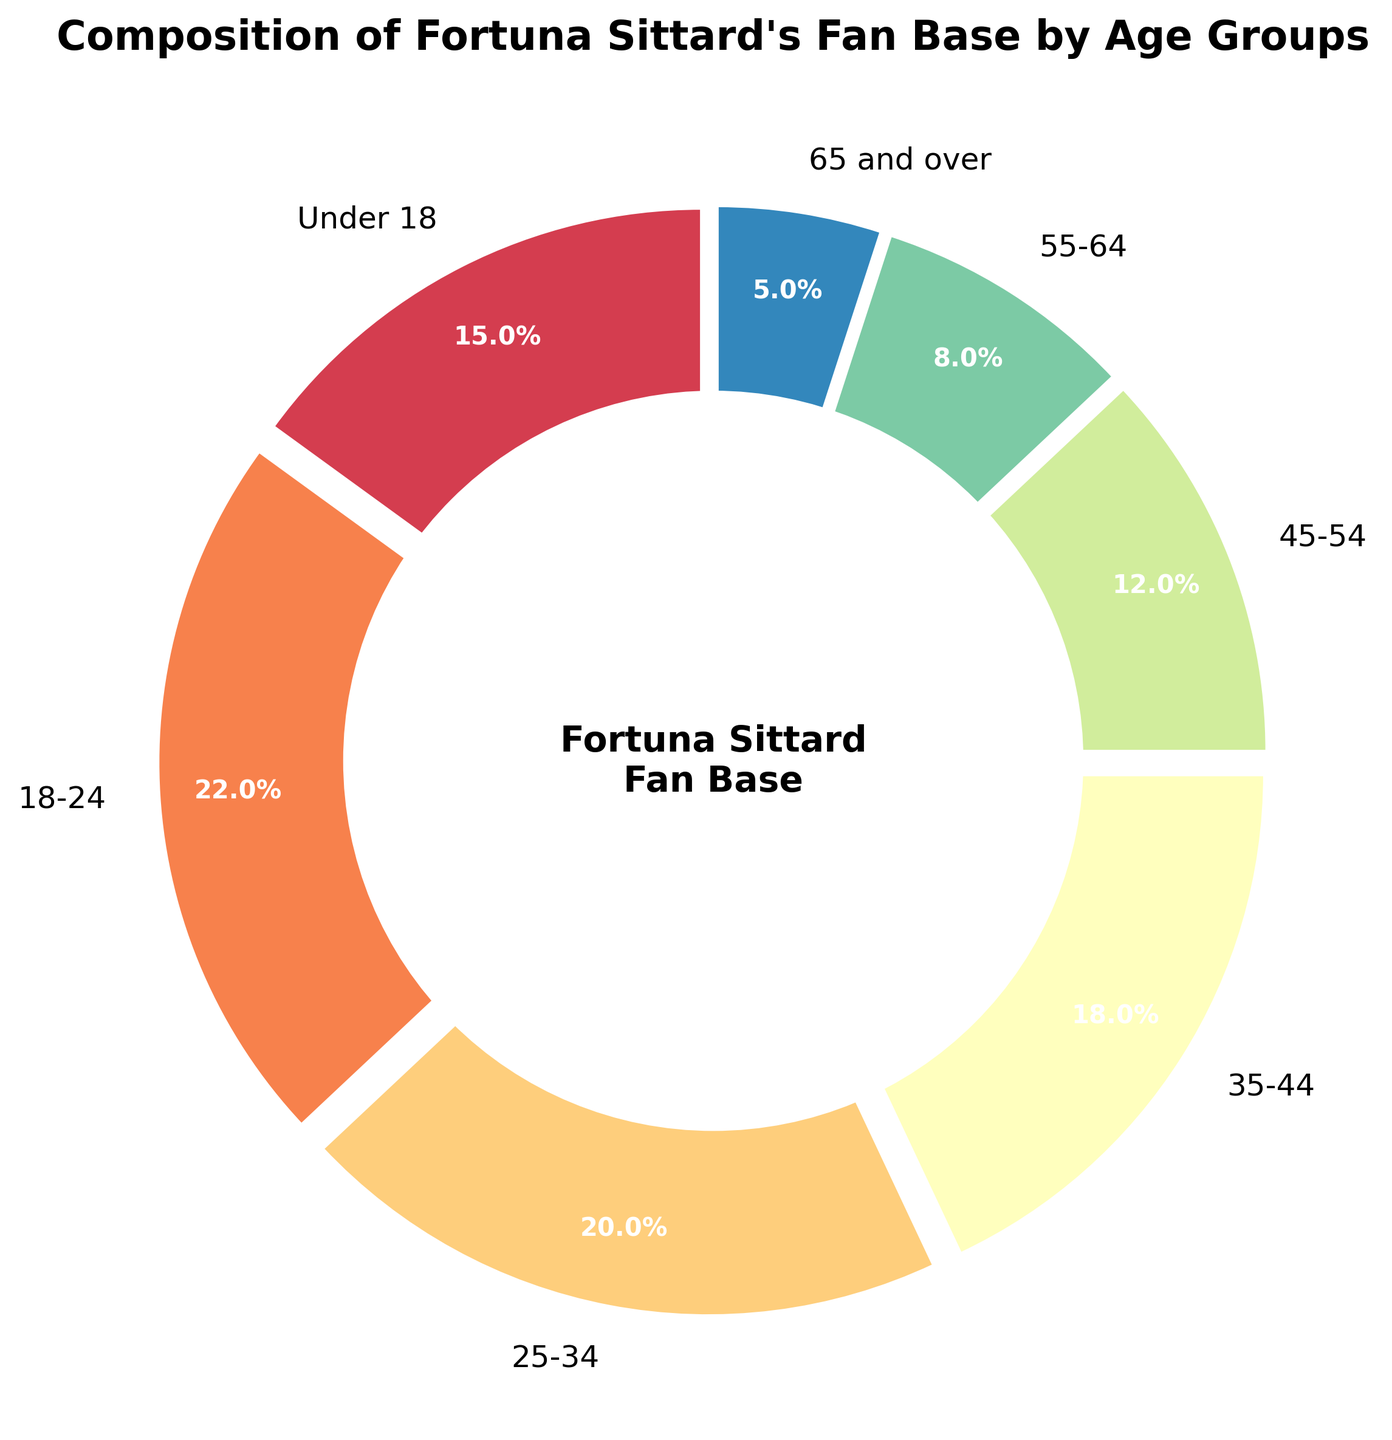What's the largest age group in the fan base? The largest age group in the fan base is identified by the segment of the pie chart with the largest percentage. The 18-24 age group makes up 22% of the fan base.
Answer: 18-24 Which age group contributes the least to the fan base? The age group with the smallest segment of the pie chart represents the smallest contribution. The 65 and over group makes up 5% of the fan base.
Answer: 65 and over What two age groups together make up more than one-third of the fan base? Two age groups need to collectively comprise more than 33.3%. The 18-24 group (22%) and the Under 18 group (15%) together make up 37%.
Answer: 18-24 and Under 18 Which two consecutive age groups together have the closest percentage to 30% of the fan base? Add the percentages of consecutive age groups and compare to 30%. The 25-34 group (20%) combined with the 35-44 group (18%) results in 38%, while the 35-44 and 45-54 groups combined make 30%.
Answer: 35-44 and 45-54 What is the mean percentage for the age groups 45-54, 55-64, and 65 and over? Calculate the mean by summing the percentages of the three groups and divide by 3. The sum is 12% + 8% + 5% = 25%, so the mean is 25% / 3.
Answer: 8.33% Are there more fans in the 35-44 group than in the 25-34 group? Compare the percentages. The 35-44 age group has 18%, while the 25-34 age group has 20%. Thus, the 25-34 group has more fans.
Answer: No Which age group has a percentage equal to the combined percentage of the 55-64 and 65 and over groups? Add the percentages of the 55-64 and 65 and over groups (8% + 5% = 13%) and see which single group matches that. None of the single age groups matches 13%.
Answer: None If you combine the Under 18 and 65 and over groups, how does their total percentage compare to that of the 25-34 group? Add the Under 18 and 65 and over groups (15% + 5% = 20%) and compare to the 25-34 group (20%). Both are equal.
Answer: Equal What percentage of the fan base is aged 55 and over? Sum the percentages for the 55-64 group (8%) and the 65 and over group (5%). The total is 8% + 5% = 13%.
Answer: 13% How many age groups have percentages above 15%? Look for age groups with more than 15%. These are Under 18 (15%), 18-24 (22%), 25-34 (20%), and 35-44 (18%). There are four such groups.
Answer: 4 